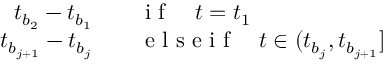<formula> <loc_0><loc_0><loc_500><loc_500>\begin{array} { r l } { t _ { b _ { 2 } } - t _ { b _ { 1 } } } & \quad i f \quad t = t _ { 1 } } \\ { t _ { b _ { j + 1 } } - t _ { b _ { j } } } & \quad e l s e i f \quad t \in ( t _ { b _ { j } } , t _ { b _ { j + 1 } } ] } \end{array}</formula> 